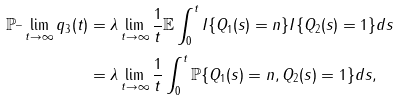Convert formula to latex. <formula><loc_0><loc_0><loc_500><loc_500>\mathbb { P } ^ { \_ } \lim _ { t \to \infty } q _ { 3 } ( t ) & = \lambda \lim _ { t \to \infty } \frac { 1 } { t } \mathbb { E } \int _ { 0 } ^ { t } I \{ Q _ { 1 } ( s ) = { n } \} I \{ Q _ { 2 } ( s ) = 1 \} d s \\ & = \lambda \lim _ { t \to \infty } \frac { 1 } { t } \int _ { 0 } ^ { t } \mathbb { P } \{ Q _ { 1 } ( s ) = { n } , Q _ { 2 } ( s ) = 1 \} d s ,</formula> 